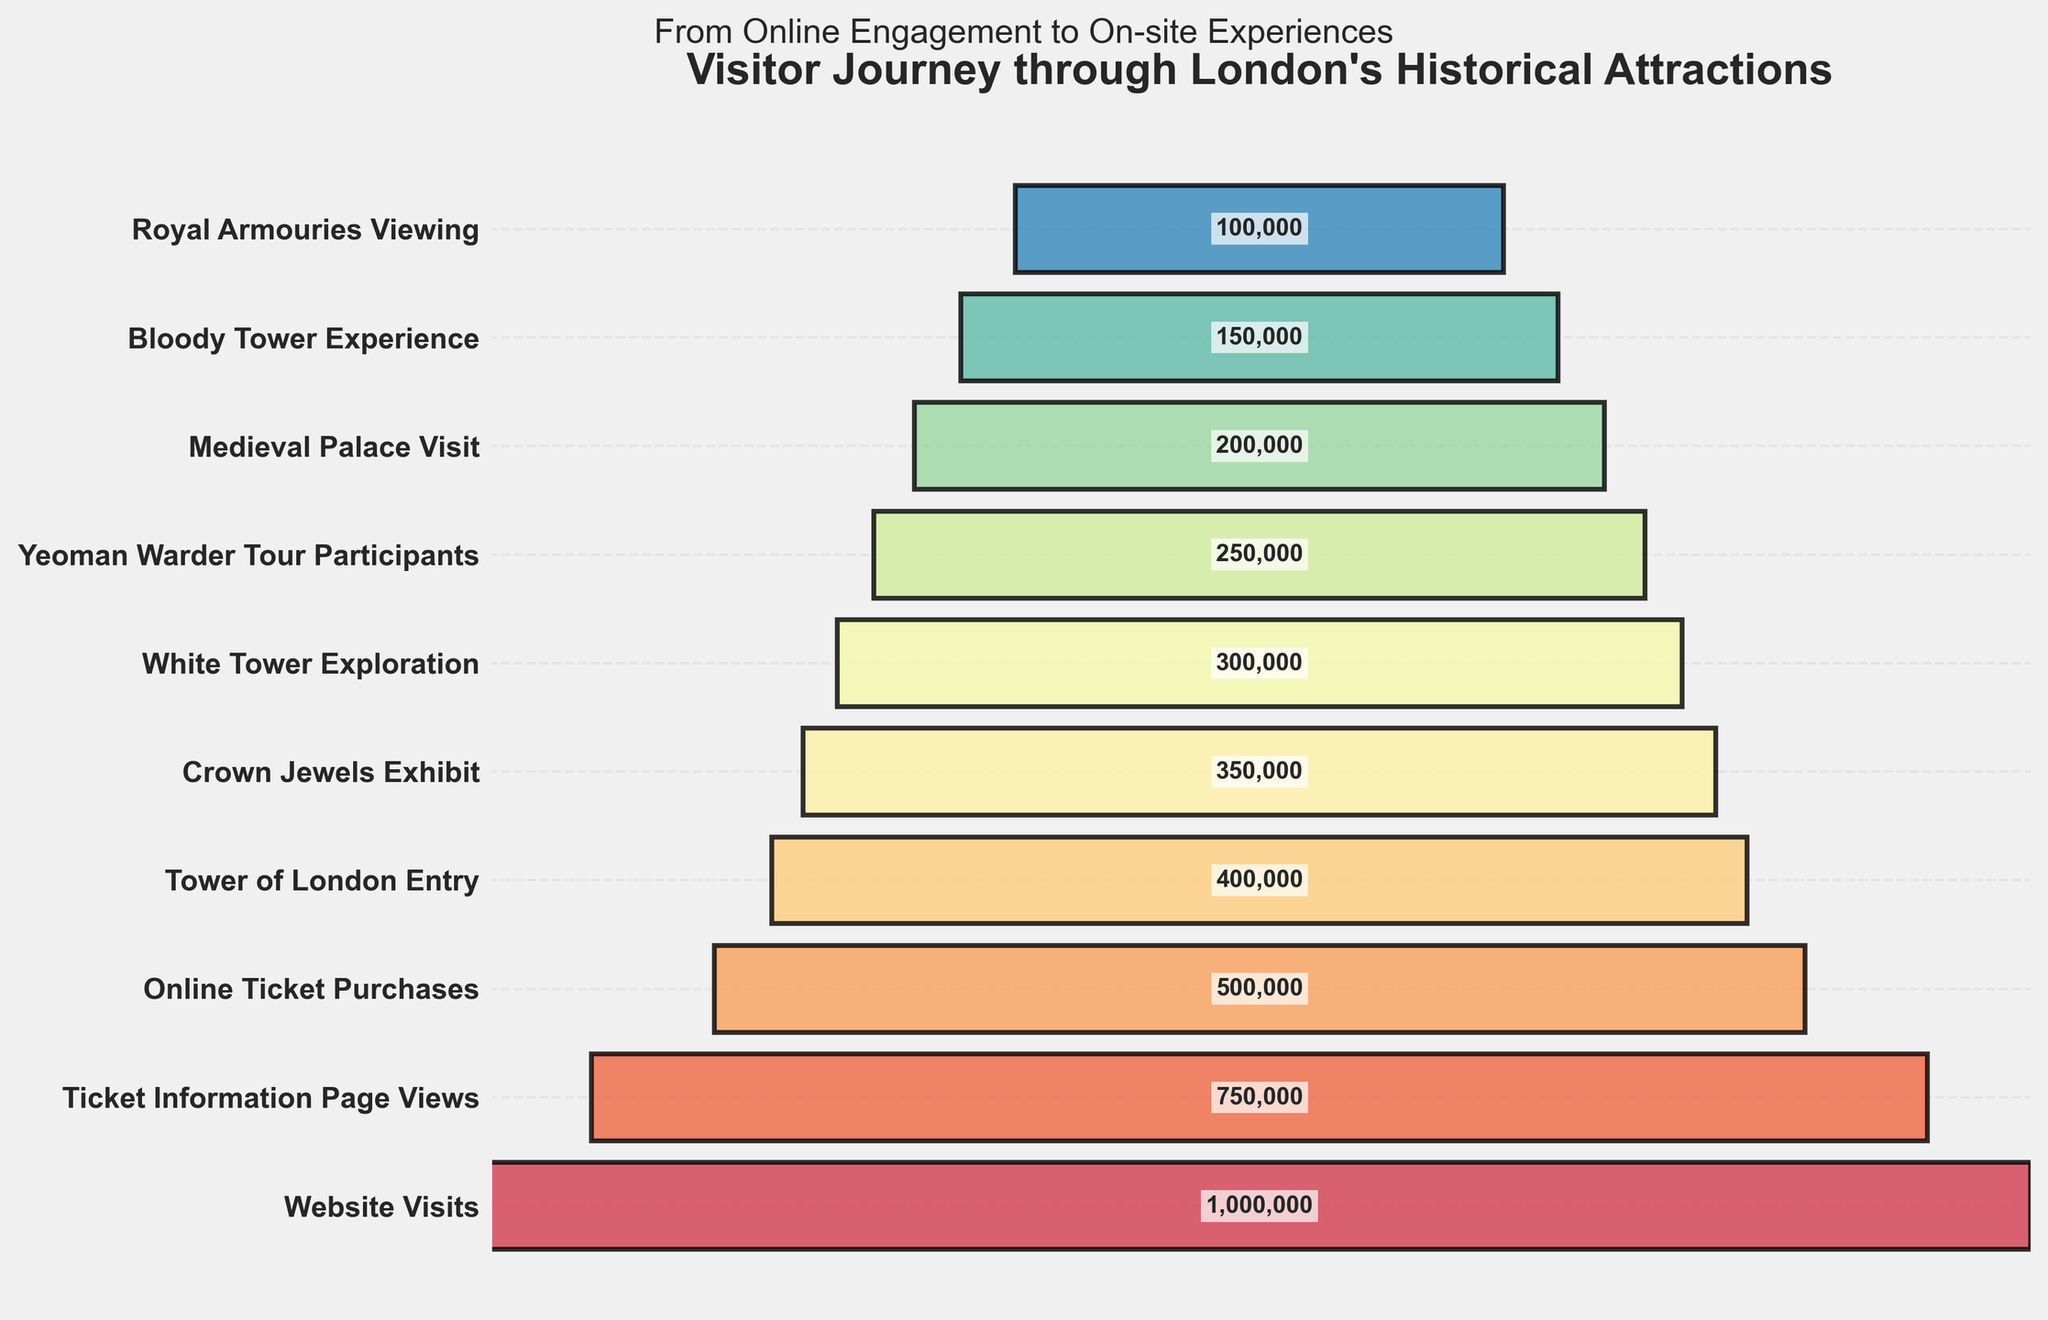what is the title of the figure? The title of the figure is prominently displayed at the top. It reads "Visitor Journey through London's Historical Attractions".
Answer: Visitor Journey through London's Historical Attractions How many stages are depicted in the funnel chart? Counting the number of unique stages labeled on the y-axis reveals there are 10 distinct stages depicted in the chart.
Answer: 10 What is the first stage called and how many visitors were at that stage? The first stage is on the topmost part of the chart, labeled "Website Visits" with 1,000,000 visitors.
Answer: Website Visits, 1,000,000 visitors Compare the number of visitors who viewed the Ticket Information Page to the number who purchased tickets online. Find the visitors for both stages "Ticket Information Page Views" (750,000) and "Online Ticket Purchases" (500,000). Subtract the latter from the former.
Answer: 250,000 fewer visitors What stage has the lowest number of visitors, and how many visitors are there? By examining the bottommost label, we find "Royal Armouries Viewing" has the lowest number of visitors, 100,000.
Answer: Royal Armouries Viewing, 100,000 visitors What percentage of website visitors eventually visited the Bloody Tower Experience? There are 1,000,000 website visitors and 150,000 visitors to the Bloody Tower Experience. The calculation is (150,000 / 1,000,000) * 100.
Answer: 15% Between which two consecutive stages is the biggest drop in visitor numbers observed? Compare the visitor numbers between each consecutive stage and find the maximum drop. The largest difference is between Online Ticket Purchases (500,000) and Tower of London Entry (400,000), a drop of 100,000.
Answer: Between Online Ticket Purchases and Tower of London Entry What is the total number of visitors who participated in the Yeoman Warder Tour and visited the White Tower? The visitors for "Yeoman Warder Tour Participants" are 250,000 and for "White Tower Exploration" are 300,000. The sum is 250,000 + 300,000.
Answer: 550,000 visitors What is the average number of visitors for the stages from "Crown Jewels Exhibit" to "Bloody Tower Experience"? There are four stages: Crown Jewels Exhibit (350,000), White Tower Exploration (300,000), Yeoman Warder Tour Participants (250,000), Medieval Palace Visit (200,000), and Bloody Tower Experience (150,000). Calculate the average by summing these figures and dividing by 5. The sum is 1,250,000 and the average is 1,250,000 / 5.
Answer: 250,000 visitors Based on the data, is it accurate to say that half of the website visitors eventually entered the Tower of London? Tower of London Entry has 400,000 visitors which is 40% of the 1,000,000 website visitors. 40% is not the same as half (50%).
Answer: No 